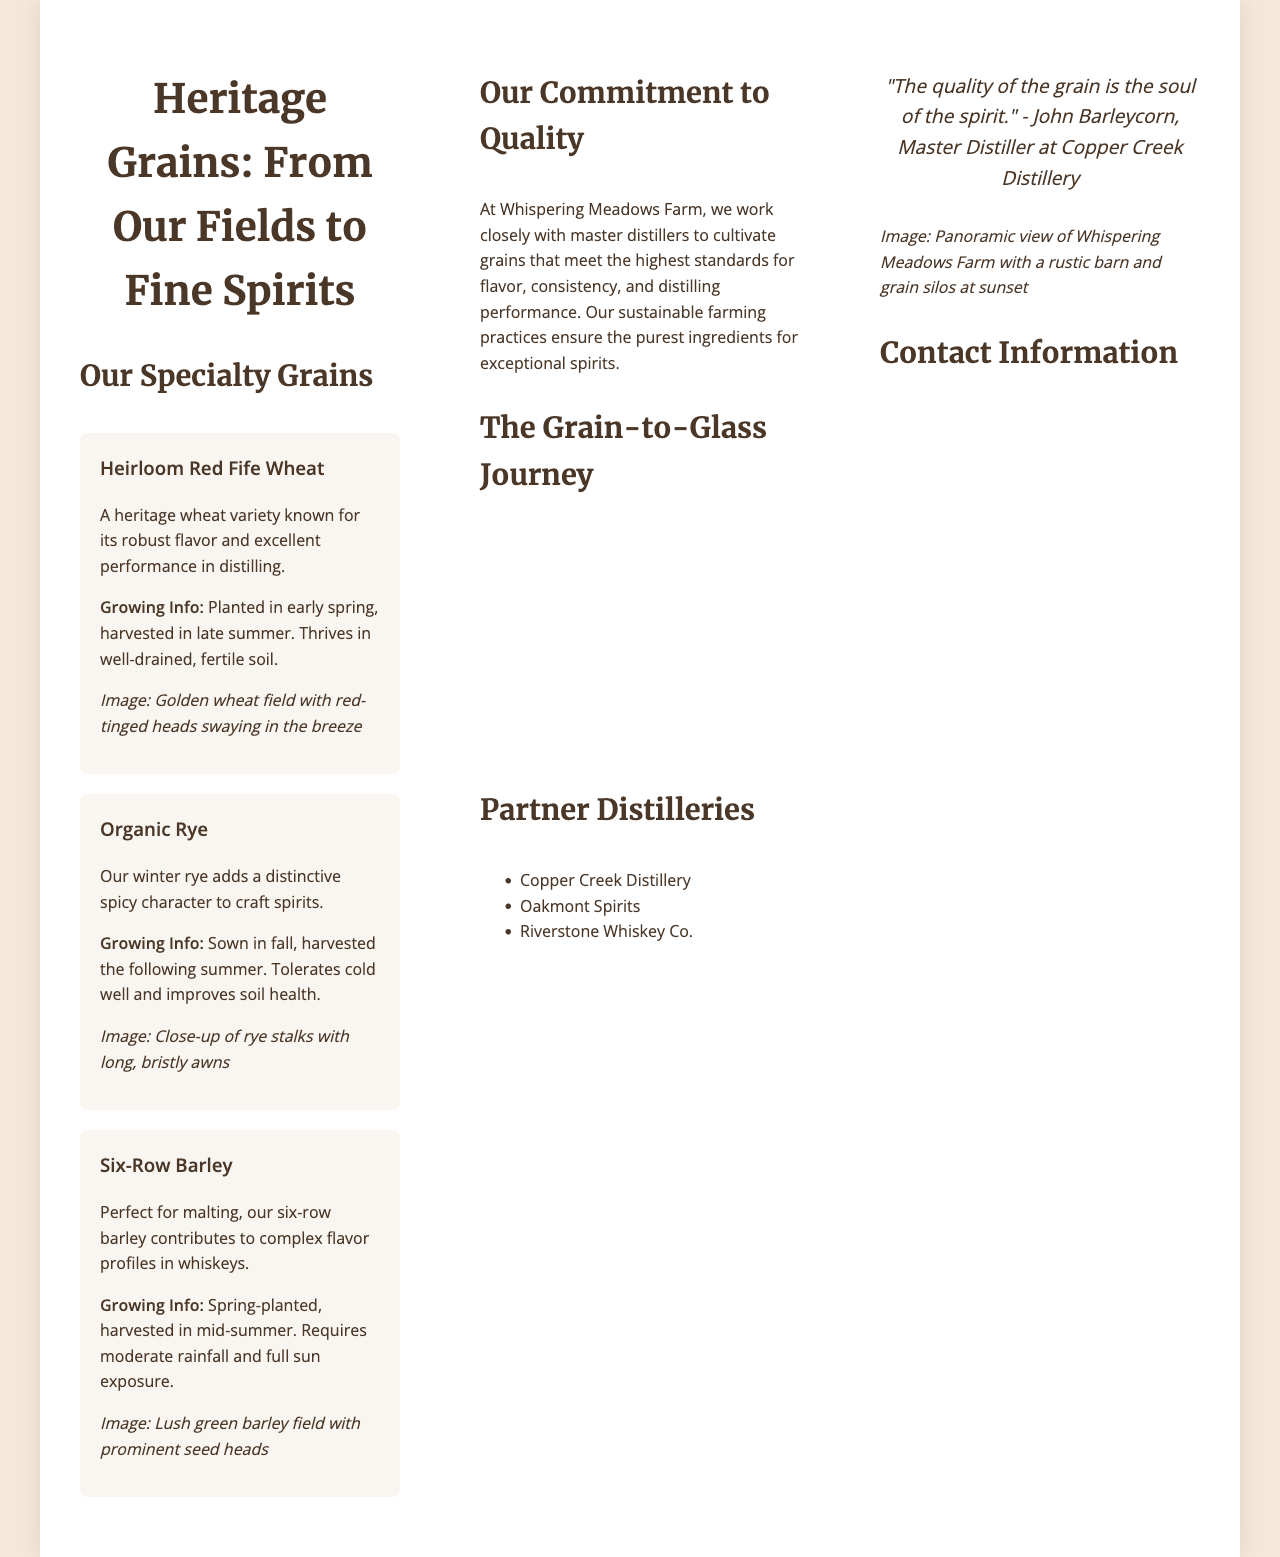What is the title of the brochure? The title of the brochure is prominently displayed at the top of the document.
Answer: Heritage Grains: From Our Fields to Fine Spirits What grain is known for its robust flavor? The document lists grains with their descriptions, highlighting one known for robust flavor.
Answer: Heirloom Red Fife Wheat What season is Organic Rye sown? The growing information section specifies when Organic Rye is sown.
Answer: Fall How many partner distilleries are listed? The document includes a list of partner distilleries, and the count can be determined directly from that list.
Answer: Three What is the primary color used in the brochure? The color scheme section provides the primary color for the brochure.
Answer: Warm golden yellow What is the last step in the grain-to-glass journey? The steps included detail the process from seed selection to delivery, allowing us to identify the final step.
Answer: Direct delivery to distilleries Which distillery quotes the phrase about grain quality? The back panel features a quote about grain quality attributed to a specific master distiller.
Answer: John Barleycorn What is the farm's email address? The contact information section contains the email address for the farm.
Answer: info@whisperingmeadowsfarm.com What type of barley is perfect for malting? The document provides specific information about the barley variety suitable for malting.
Answer: Six-Row Barley 